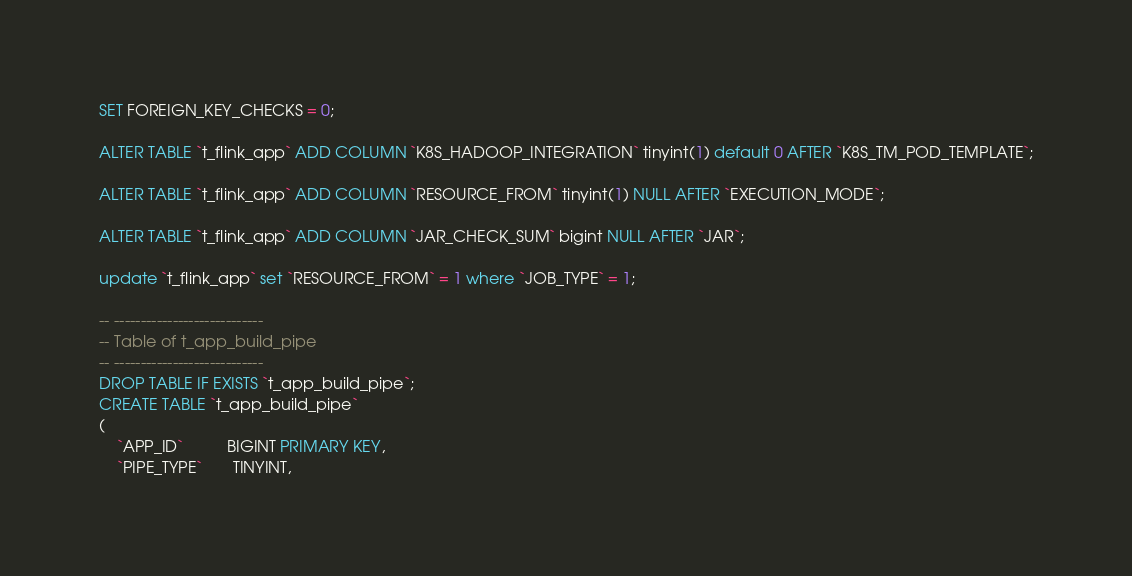Convert code to text. <code><loc_0><loc_0><loc_500><loc_500><_SQL_>SET FOREIGN_KEY_CHECKS = 0;

ALTER TABLE `t_flink_app` ADD COLUMN `K8S_HADOOP_INTEGRATION` tinyint(1) default 0 AFTER `K8S_TM_POD_TEMPLATE`;

ALTER TABLE `t_flink_app` ADD COLUMN `RESOURCE_FROM` tinyint(1) NULL AFTER `EXECUTION_MODE`;

ALTER TABLE `t_flink_app` ADD COLUMN `JAR_CHECK_SUM` bigint NULL AFTER `JAR`;

update `t_flink_app` set `RESOURCE_FROM` = 1 where `JOB_TYPE` = 1;

-- ----------------------------
-- Table of t_app_build_pipe
-- ----------------------------
DROP TABLE IF EXISTS `t_app_build_pipe`;
CREATE TABLE `t_app_build_pipe`
(
    `APP_ID`          BIGINT PRIMARY KEY,
    `PIPE_TYPE`       TINYINT,</code> 